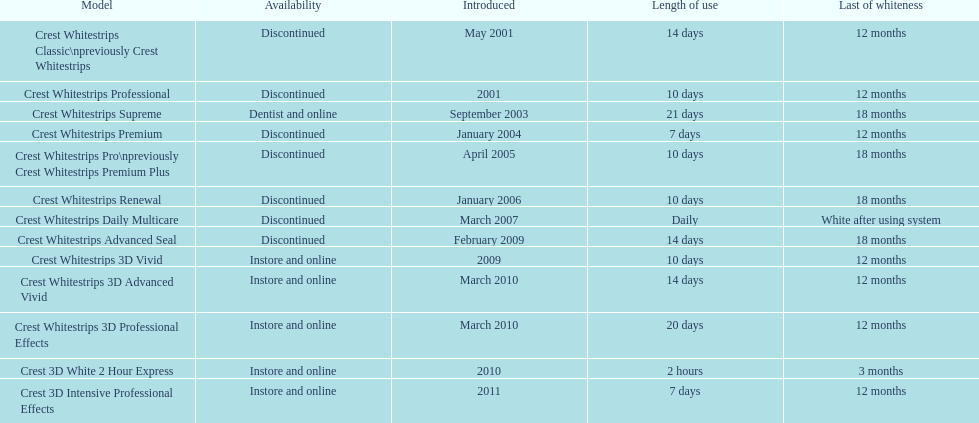Crest 3d intensive professional effects and crest whitestrips 3d professional effects both provide a long-lasting whiteness for how many months? 12 months. 